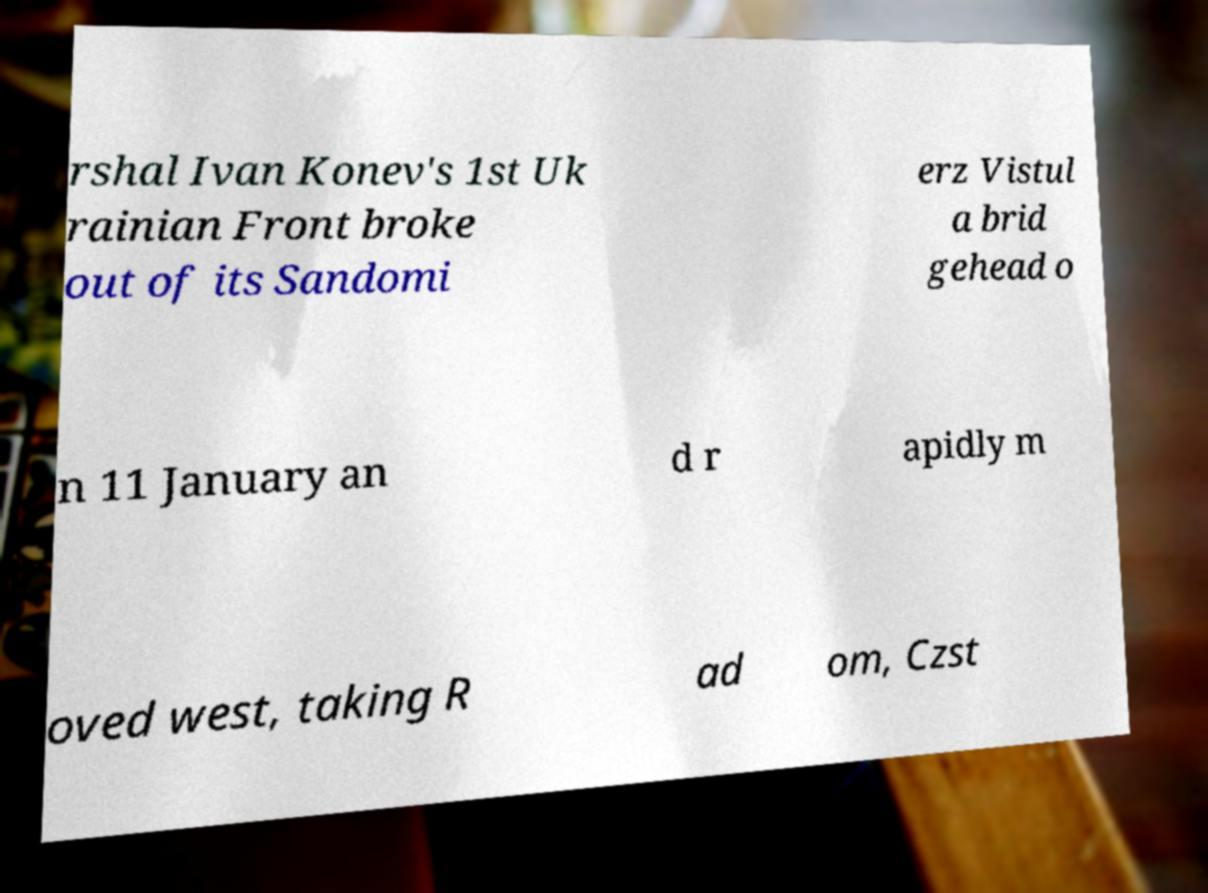What messages or text are displayed in this image? I need them in a readable, typed format. rshal Ivan Konev's 1st Uk rainian Front broke out of its Sandomi erz Vistul a brid gehead o n 11 January an d r apidly m oved west, taking R ad om, Czst 